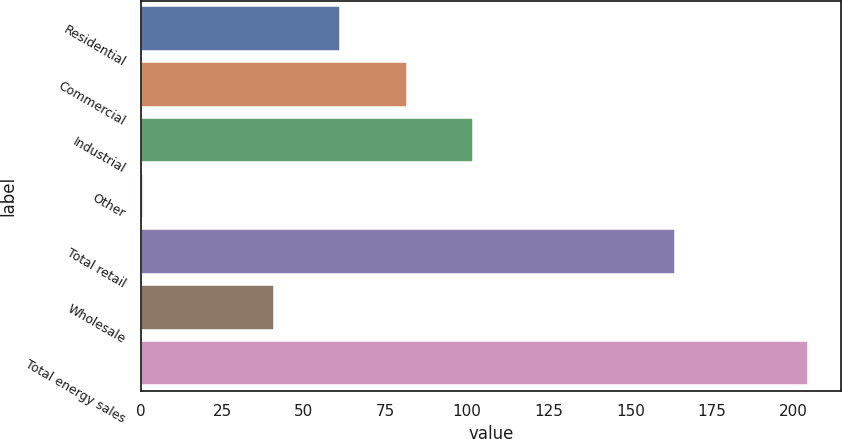Convert chart. <chart><loc_0><loc_0><loc_500><loc_500><bar_chart><fcel>Residential<fcel>Commercial<fcel>Industrial<fcel>Other<fcel>Total retail<fcel>Wholesale<fcel>Total energy sales<nl><fcel>61.15<fcel>81.5<fcel>101.85<fcel>0.9<fcel>163.6<fcel>40.8<fcel>204.4<nl></chart> 